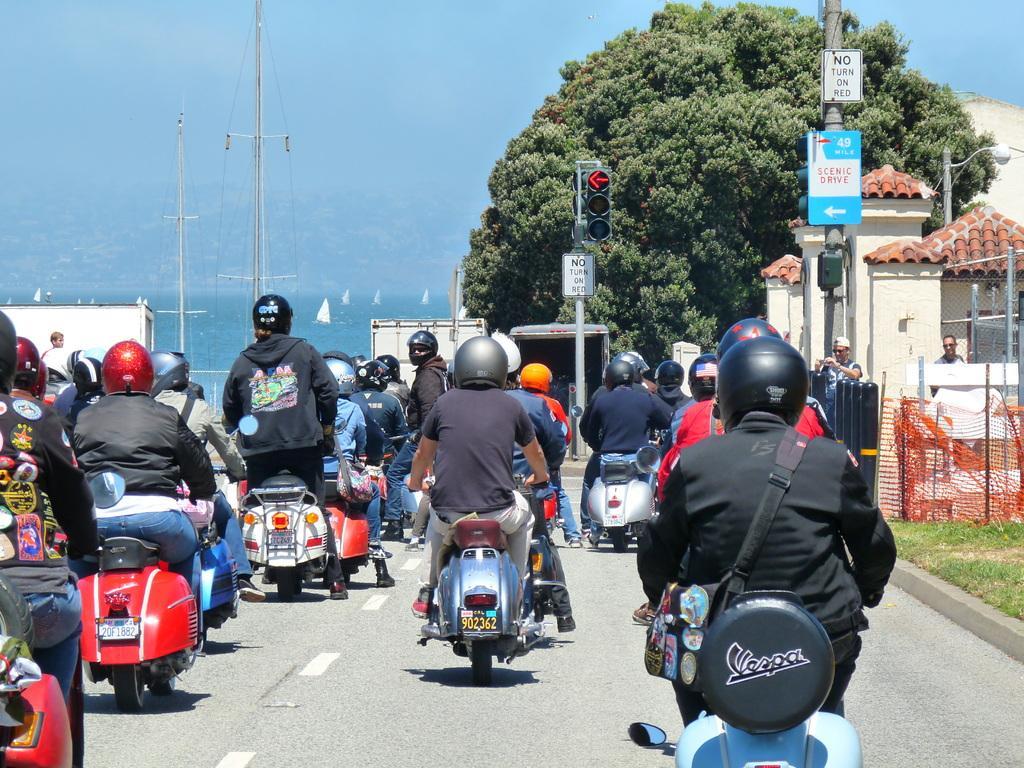Please provide a concise description of this image. This picture is taken on the road. On the road, there are people riding on the scooters and they are wearing helmets. All the people are facing backwards. Towards the right, there are buildings and people. On the top, there are trees, ocean and a sky. 